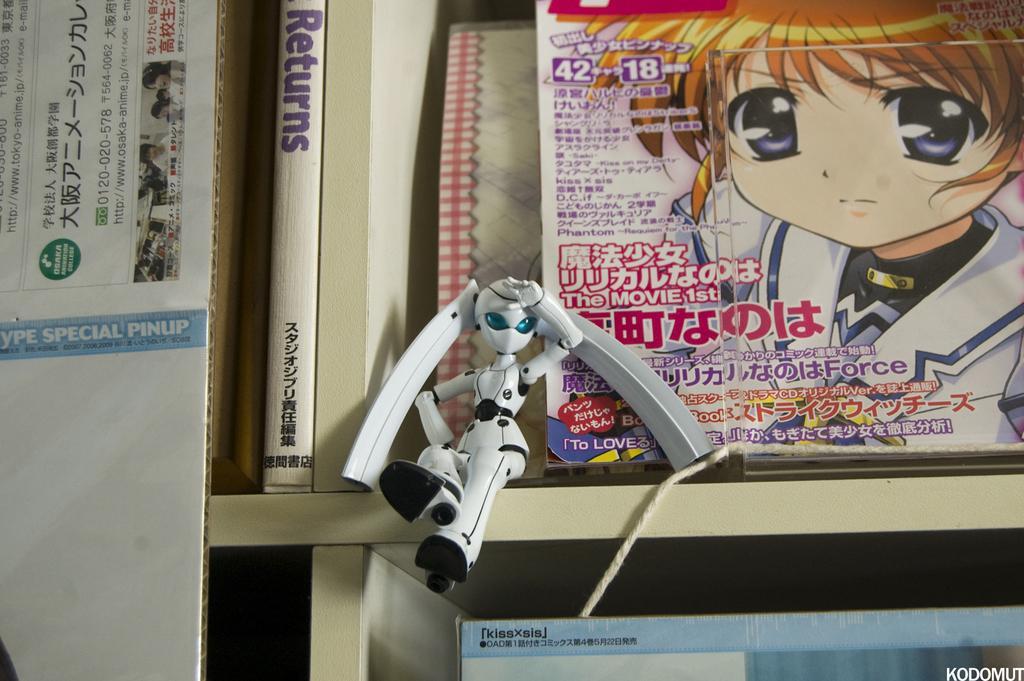How would you summarize this image in a sentence or two? In the foreground of this picture, there is a toy robot sitting at the edge of the shelf. In the background, there is a shelf with books. 